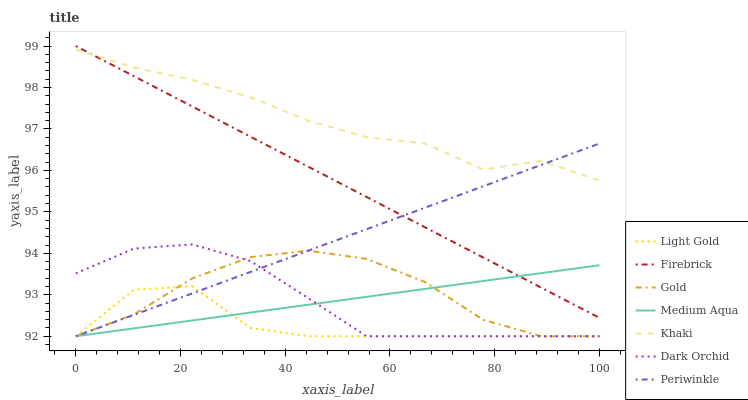Does Light Gold have the minimum area under the curve?
Answer yes or no. Yes. Does Khaki have the maximum area under the curve?
Answer yes or no. Yes. Does Gold have the minimum area under the curve?
Answer yes or no. No. Does Gold have the maximum area under the curve?
Answer yes or no. No. Is Firebrick the smoothest?
Answer yes or no. Yes. Is Light Gold the roughest?
Answer yes or no. Yes. Is Gold the smoothest?
Answer yes or no. No. Is Gold the roughest?
Answer yes or no. No. Does Gold have the lowest value?
Answer yes or no. Yes. Does Firebrick have the lowest value?
Answer yes or no. No. Does Firebrick have the highest value?
Answer yes or no. Yes. Does Gold have the highest value?
Answer yes or no. No. Is Dark Orchid less than Firebrick?
Answer yes or no. Yes. Is Khaki greater than Medium Aqua?
Answer yes or no. Yes. Does Gold intersect Periwinkle?
Answer yes or no. Yes. Is Gold less than Periwinkle?
Answer yes or no. No. Is Gold greater than Periwinkle?
Answer yes or no. No. Does Dark Orchid intersect Firebrick?
Answer yes or no. No. 